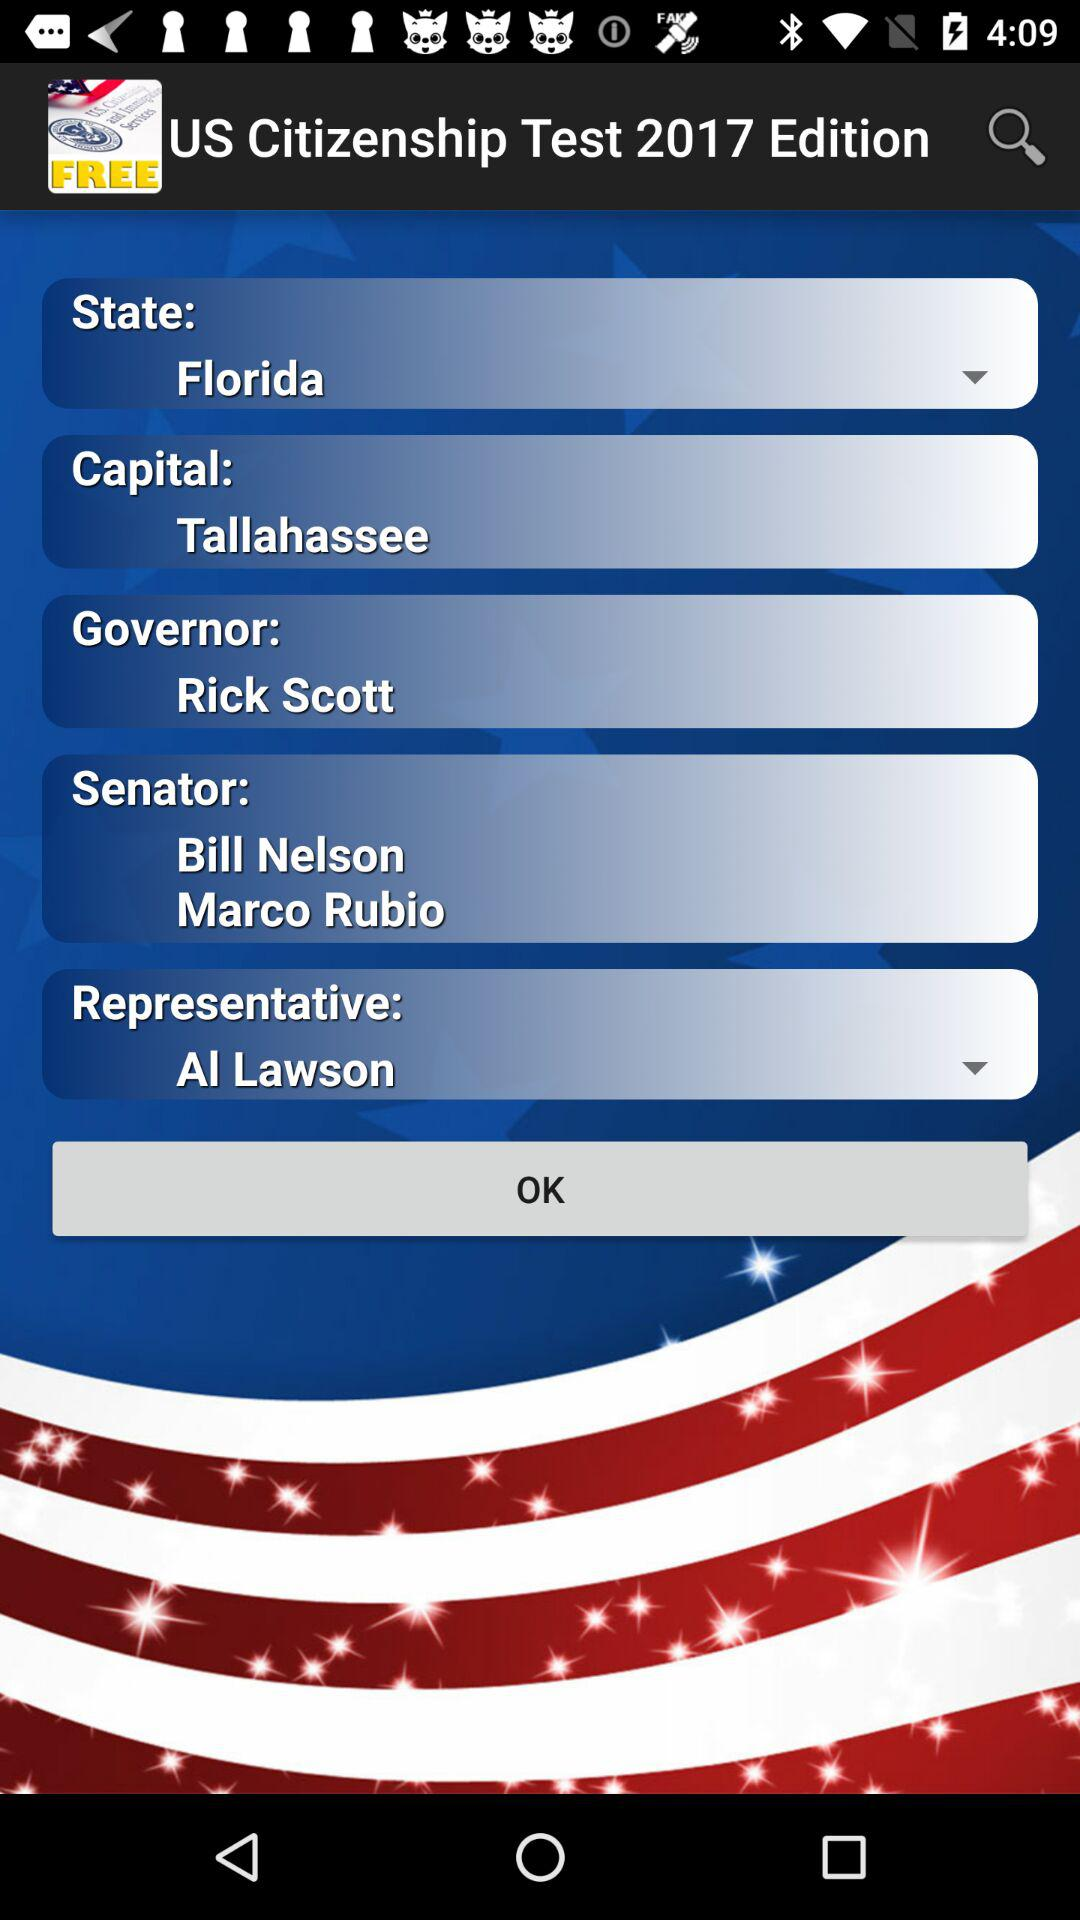What is the name of the selected state? The name of the selected state is Florida. 